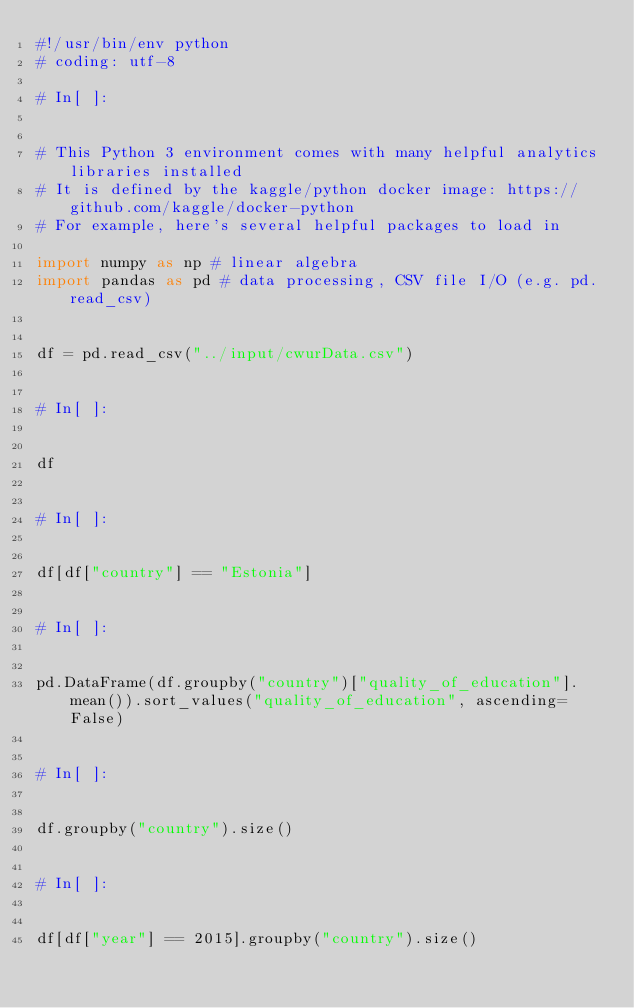Convert code to text. <code><loc_0><loc_0><loc_500><loc_500><_Python_>#!/usr/bin/env python
# coding: utf-8

# In[ ]:


# This Python 3 environment comes with many helpful analytics libraries installed
# It is defined by the kaggle/python docker image: https://github.com/kaggle/docker-python
# For example, here's several helpful packages to load in 

import numpy as np # linear algebra
import pandas as pd # data processing, CSV file I/O (e.g. pd.read_csv)


df = pd.read_csv("../input/cwurData.csv")


# In[ ]:


df


# In[ ]:


df[df["country"] == "Estonia"]


# In[ ]:


pd.DataFrame(df.groupby("country")["quality_of_education"].mean()).sort_values("quality_of_education", ascending=False)


# In[ ]:


df.groupby("country").size()


# In[ ]:


df[df["year"] == 2015].groupby("country").size()

</code> 